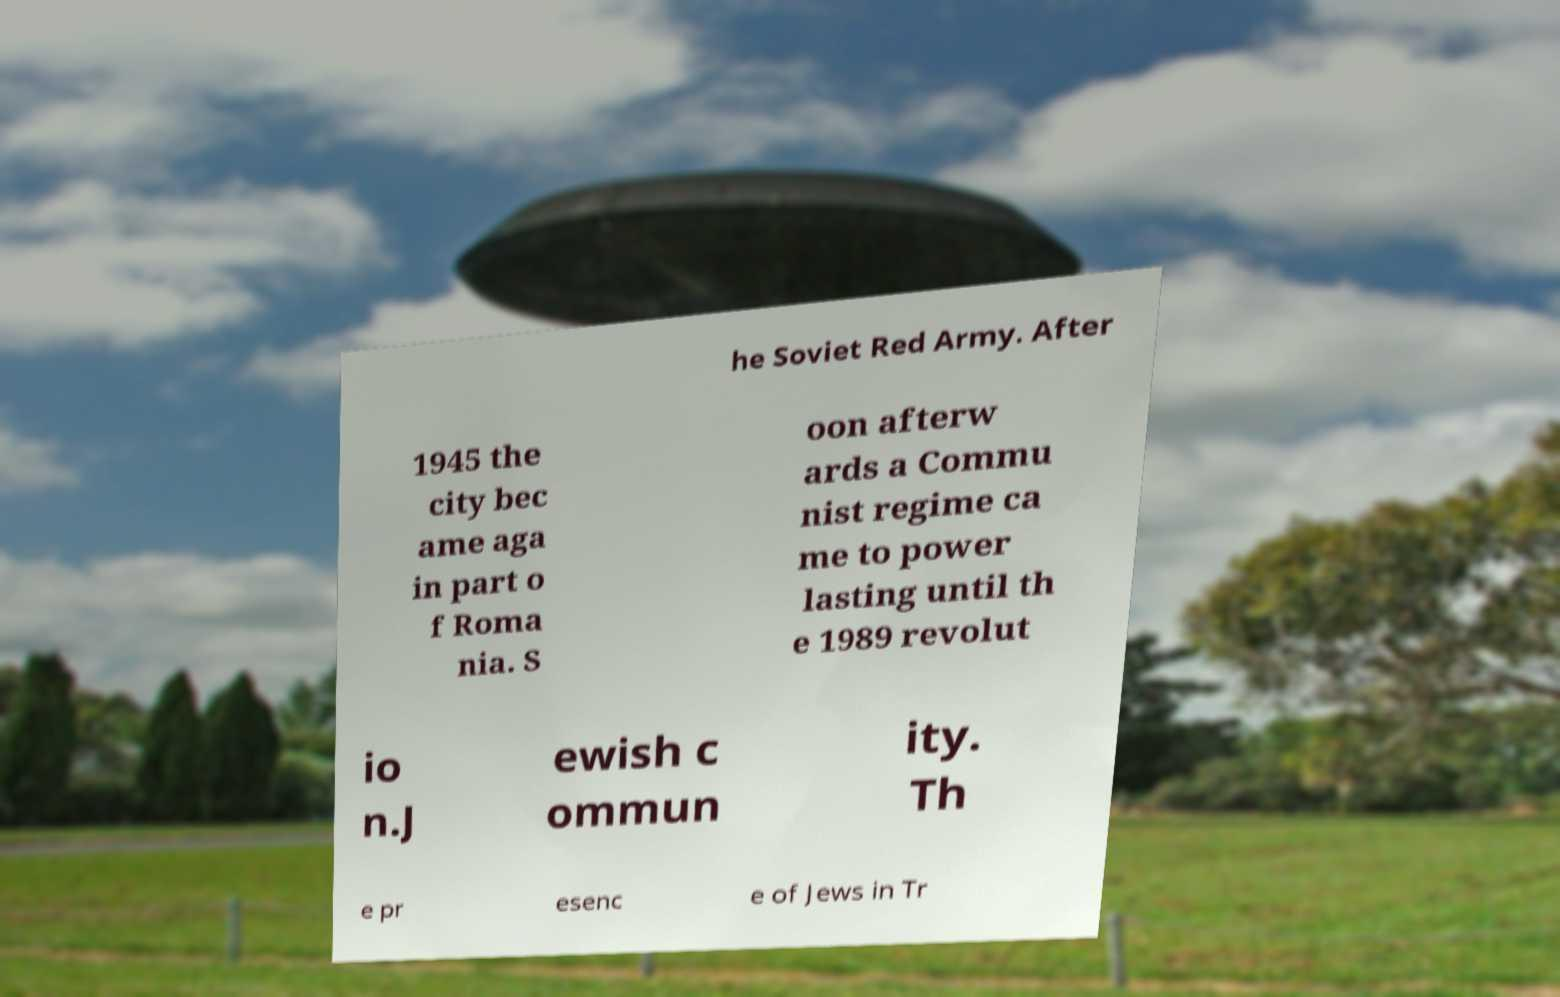Can you read and provide the text displayed in the image?This photo seems to have some interesting text. Can you extract and type it out for me? he Soviet Red Army. After 1945 the city bec ame aga in part o f Roma nia. S oon afterw ards a Commu nist regime ca me to power lasting until th e 1989 revolut io n.J ewish c ommun ity. Th e pr esenc e of Jews in Tr 